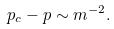Convert formula to latex. <formula><loc_0><loc_0><loc_500><loc_500>p _ { c } - p \sim m ^ { - 2 } .</formula> 